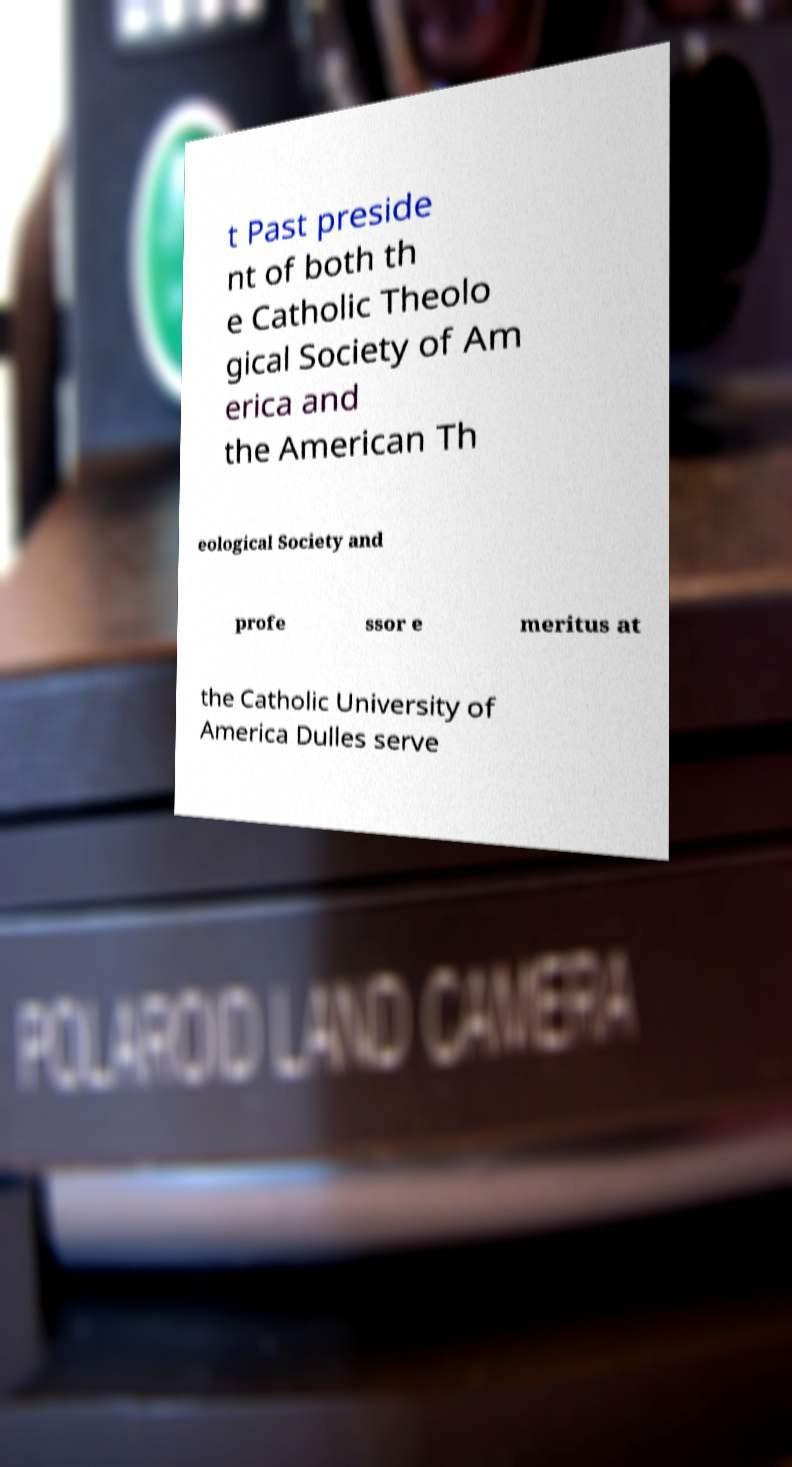Can you read and provide the text displayed in the image?This photo seems to have some interesting text. Can you extract and type it out for me? t Past preside nt of both th e Catholic Theolo gical Society of Am erica and the American Th eological Society and profe ssor e meritus at the Catholic University of America Dulles serve 